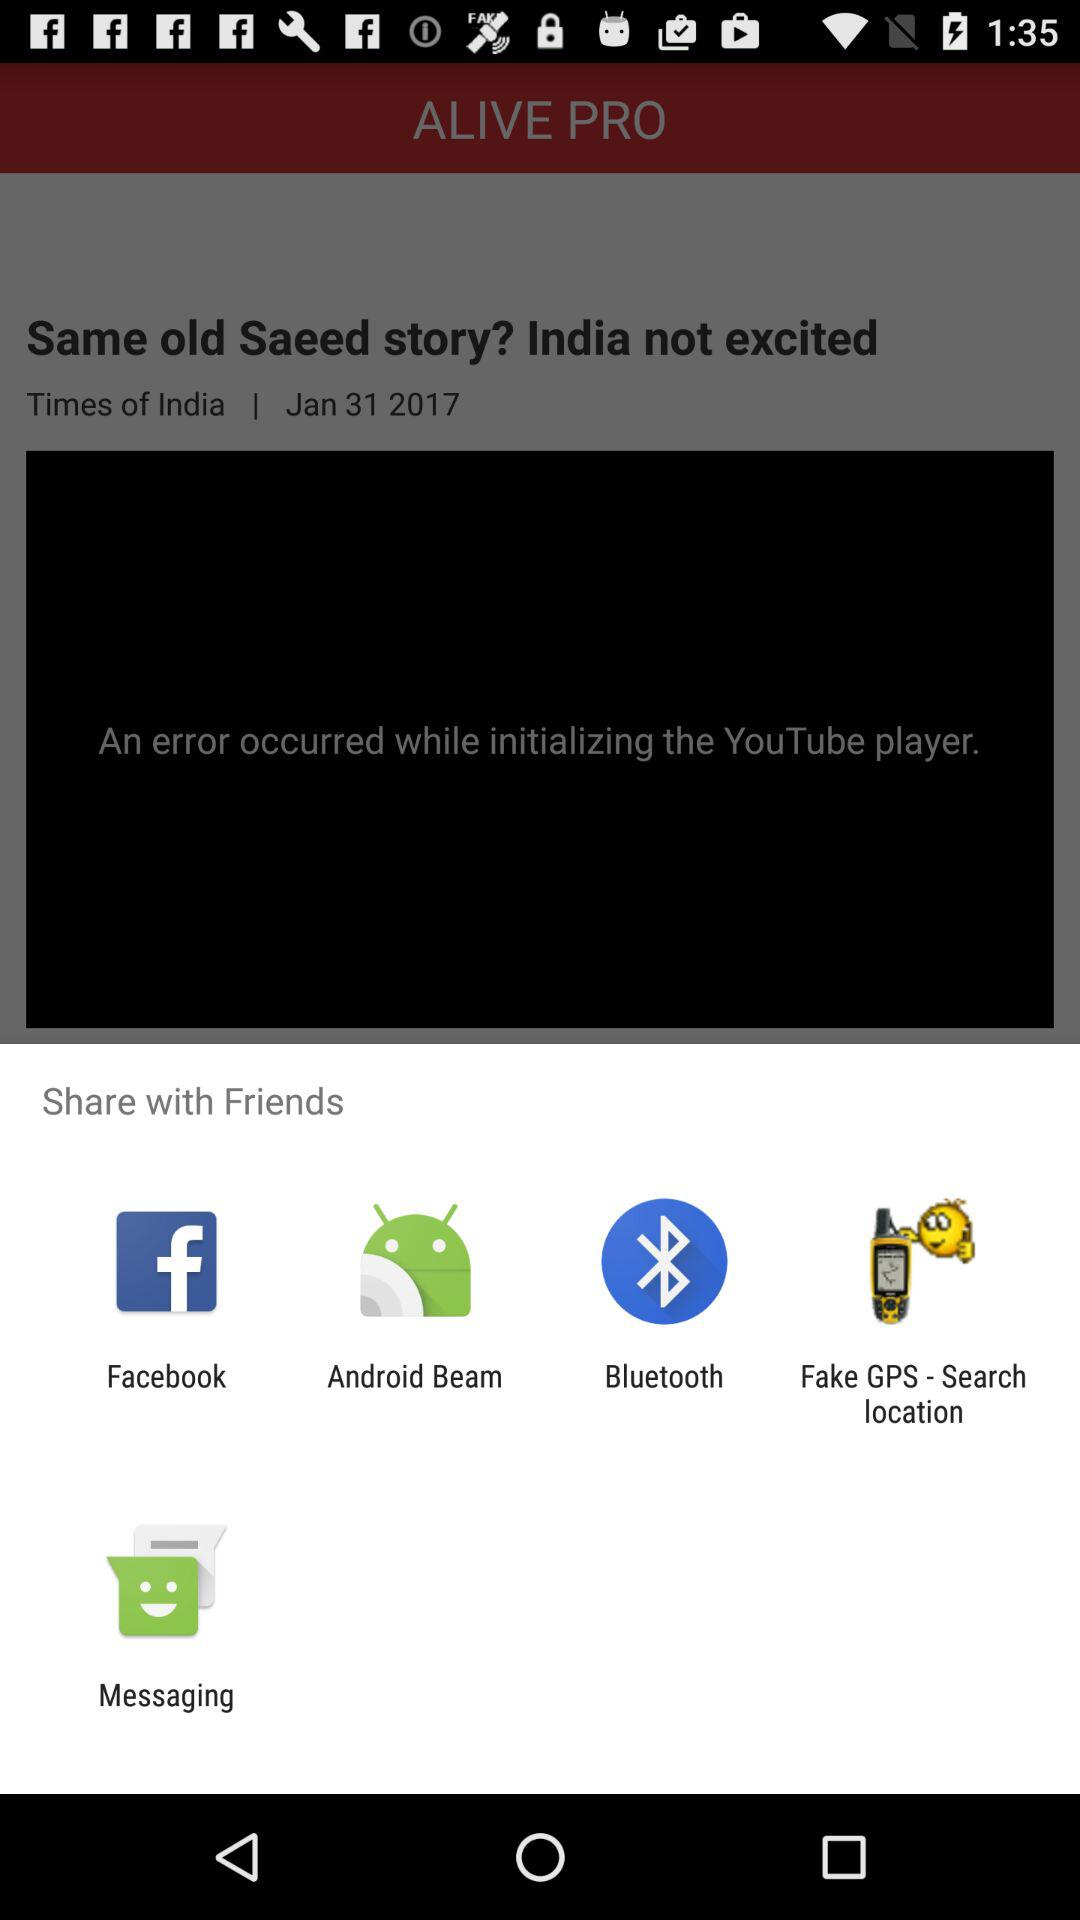What are the different applications through which we can share? You can share through "Facebook", "Android Beam", "Bluetooth", "Fake GPS - Search location" and "Messaging". 